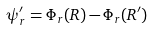<formula> <loc_0><loc_0><loc_500><loc_500>\psi ^ { \prime } _ { r } = \Phi _ { r } ( { R } ) - \Phi _ { r } ( { R } ^ { \prime } )</formula> 